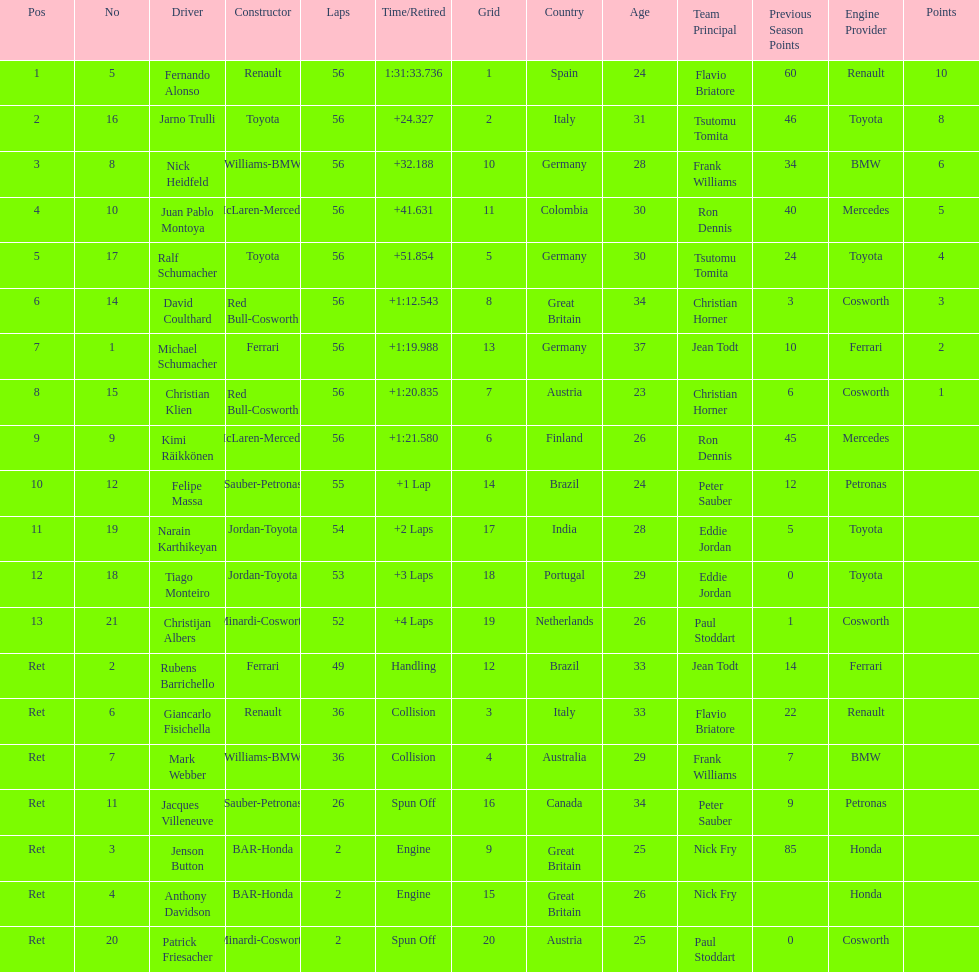What driver finished first? Fernando Alonso. 